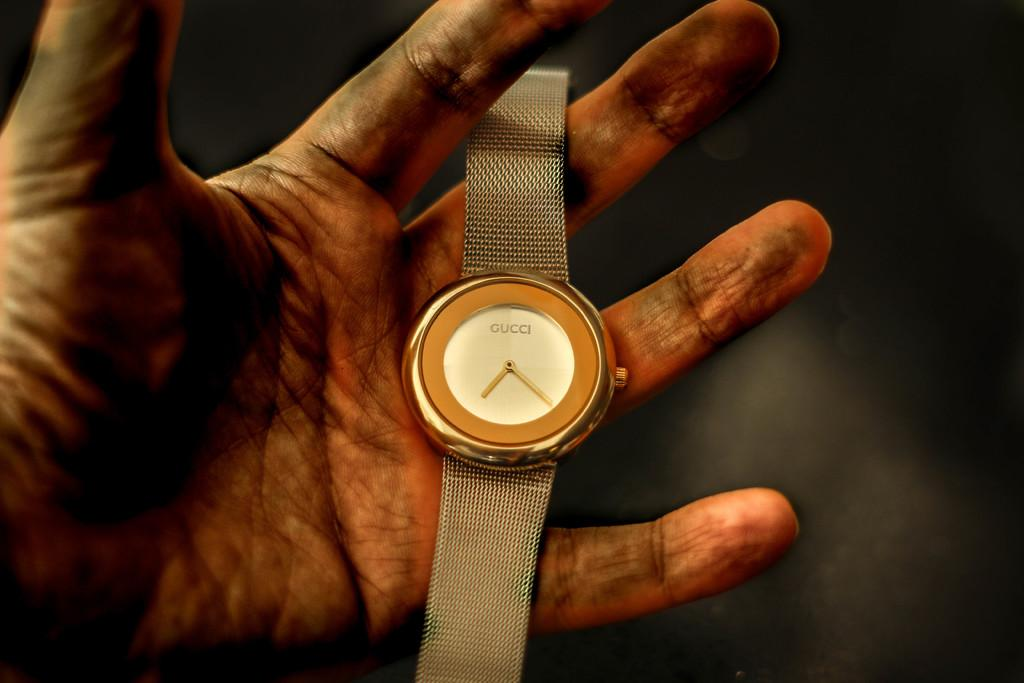<image>
Summarize the visual content of the image. a gold gucci watch and a man with very dirty hands holding it 